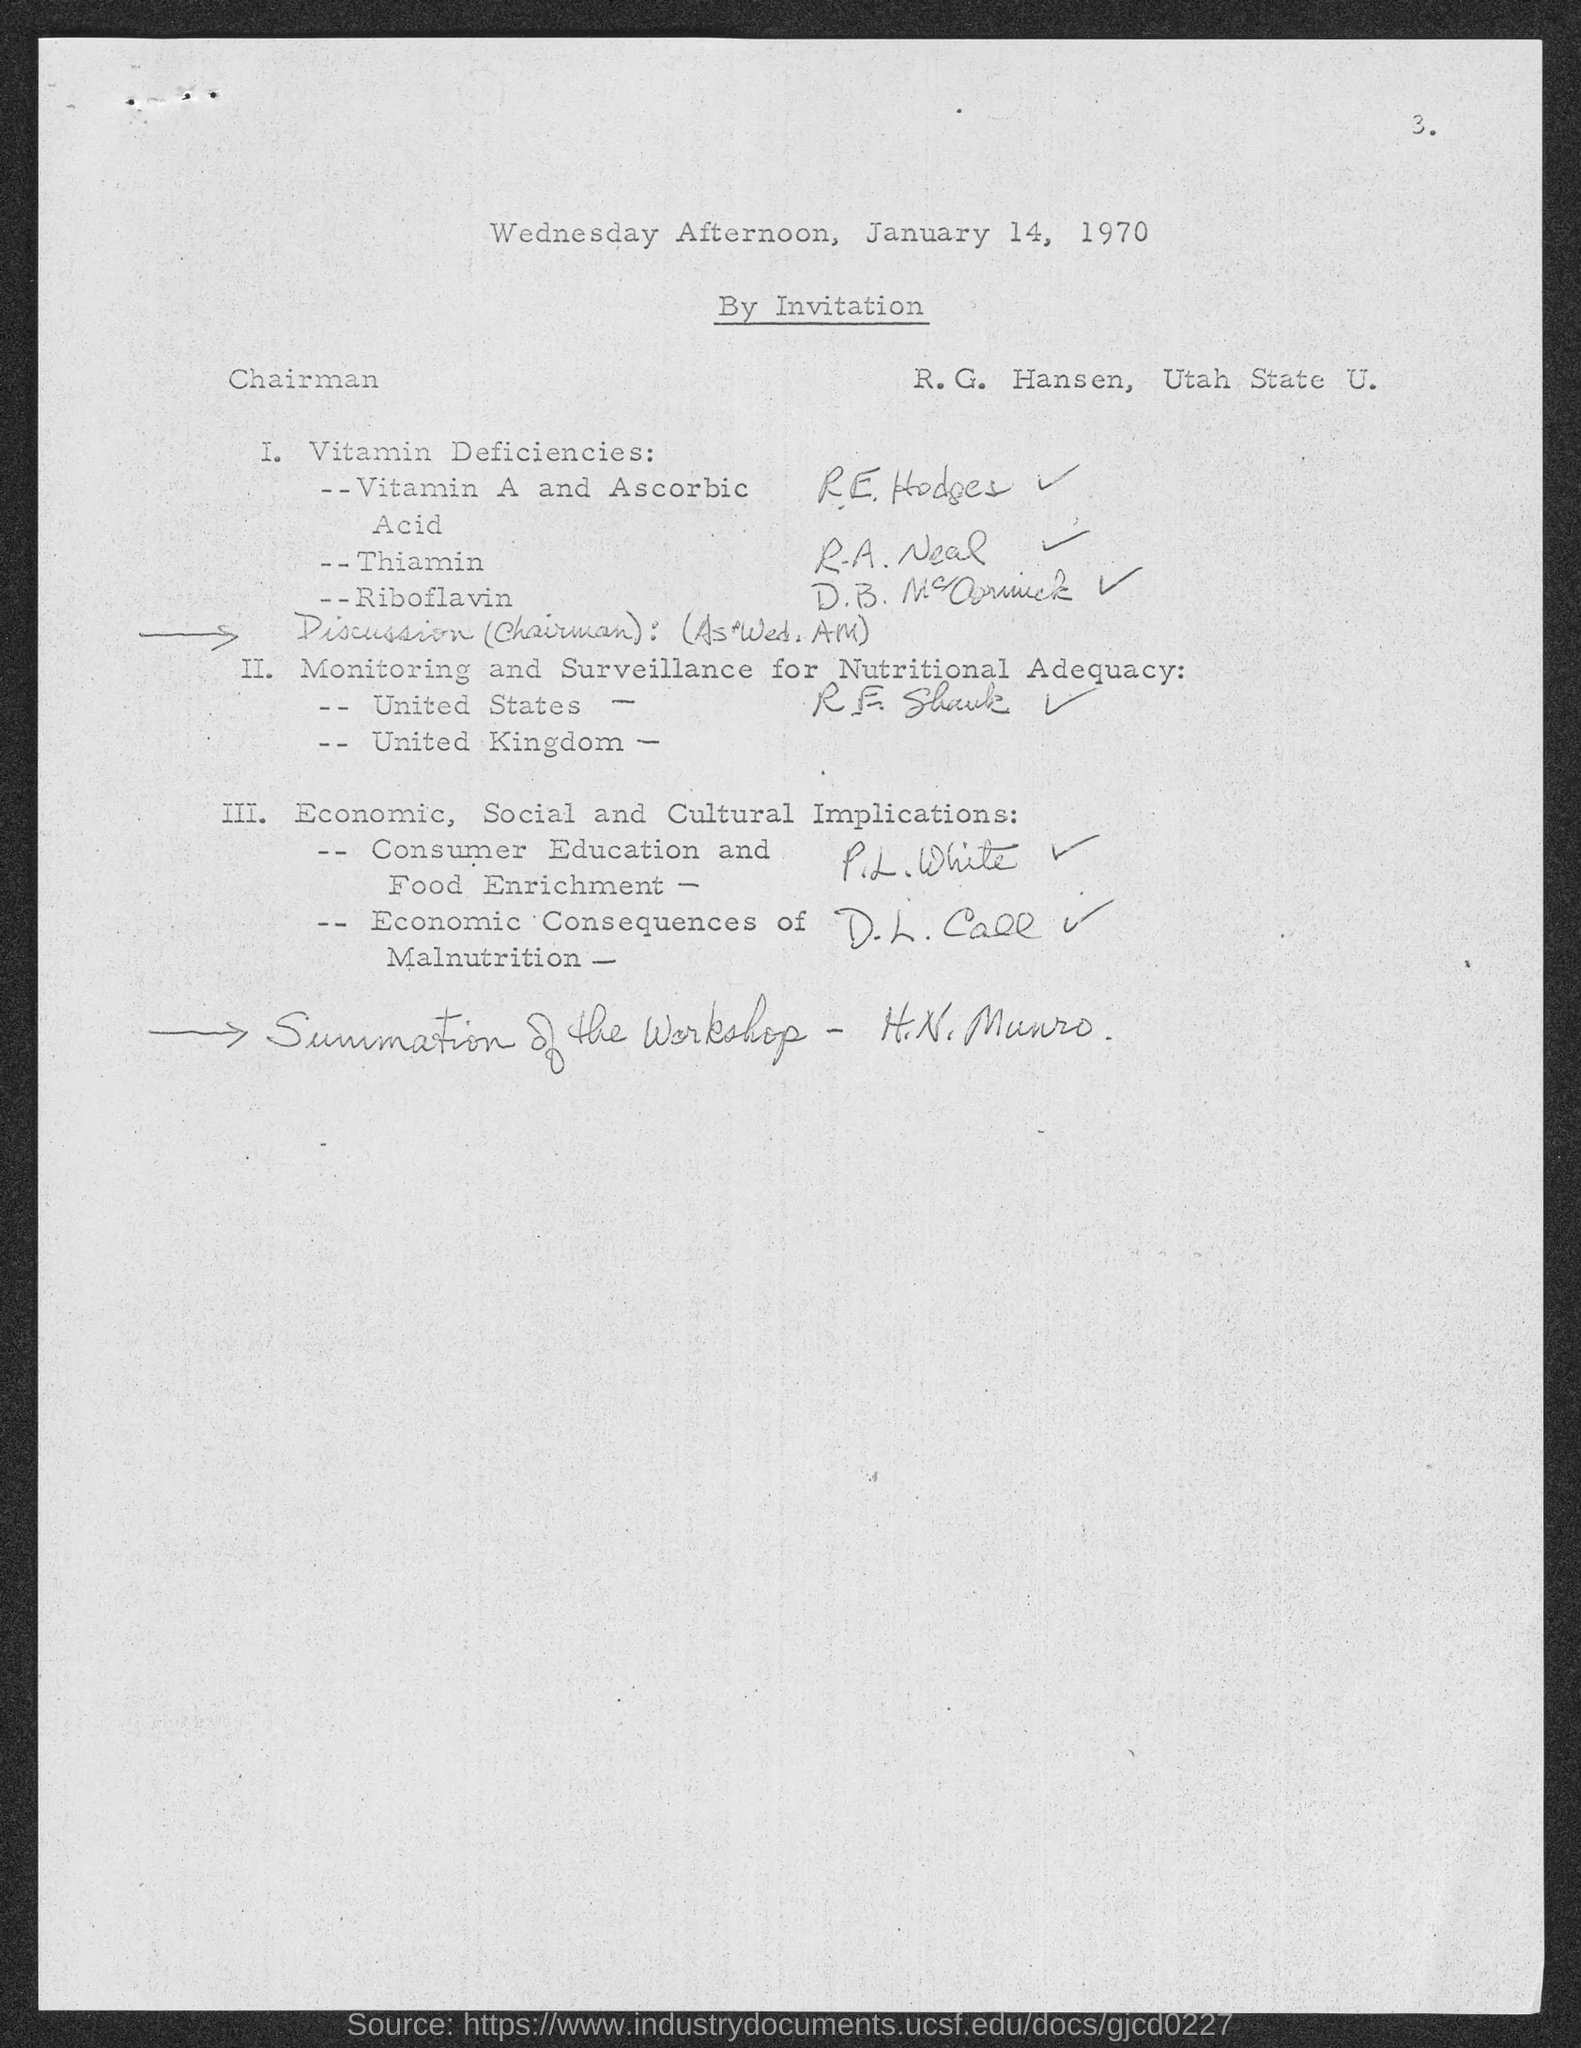Indicate a few pertinent items in this graphic. R. E. Hodges is responsible for managing vitamin A and ascorbic acid. The date of the document is January 14, 1970. 